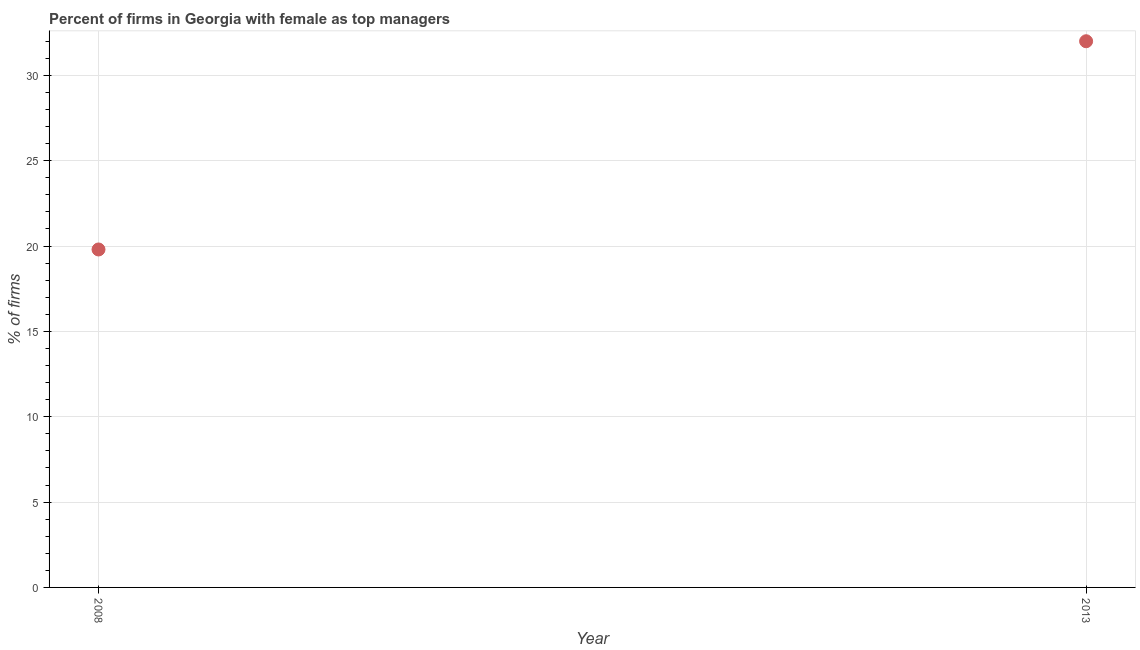Across all years, what is the maximum percentage of firms with female as top manager?
Your answer should be compact. 32. Across all years, what is the minimum percentage of firms with female as top manager?
Your answer should be compact. 19.8. In which year was the percentage of firms with female as top manager minimum?
Give a very brief answer. 2008. What is the sum of the percentage of firms with female as top manager?
Offer a terse response. 51.8. What is the difference between the percentage of firms with female as top manager in 2008 and 2013?
Give a very brief answer. -12.2. What is the average percentage of firms with female as top manager per year?
Your response must be concise. 25.9. What is the median percentage of firms with female as top manager?
Your response must be concise. 25.9. What is the ratio of the percentage of firms with female as top manager in 2008 to that in 2013?
Your answer should be compact. 0.62. Is the percentage of firms with female as top manager in 2008 less than that in 2013?
Provide a succinct answer. Yes. In how many years, is the percentage of firms with female as top manager greater than the average percentage of firms with female as top manager taken over all years?
Ensure brevity in your answer.  1. Does the percentage of firms with female as top manager monotonically increase over the years?
Ensure brevity in your answer.  Yes. What is the difference between two consecutive major ticks on the Y-axis?
Provide a succinct answer. 5. Does the graph contain any zero values?
Your response must be concise. No. Does the graph contain grids?
Make the answer very short. Yes. What is the title of the graph?
Offer a very short reply. Percent of firms in Georgia with female as top managers. What is the label or title of the Y-axis?
Provide a succinct answer. % of firms. What is the % of firms in 2008?
Your response must be concise. 19.8. What is the difference between the % of firms in 2008 and 2013?
Offer a terse response. -12.2. What is the ratio of the % of firms in 2008 to that in 2013?
Offer a terse response. 0.62. 